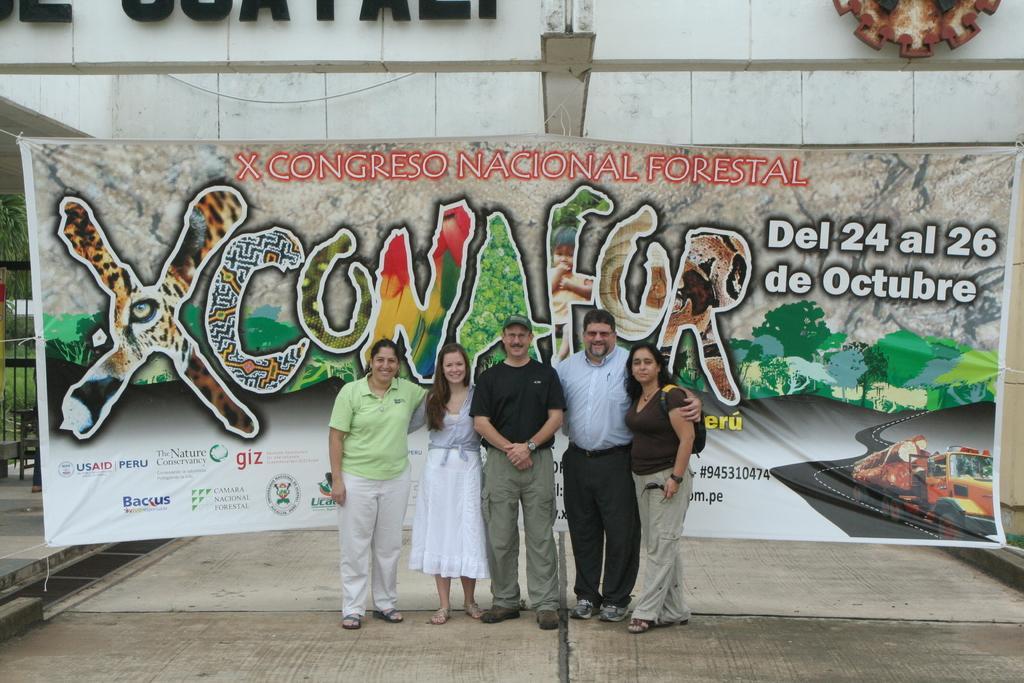Can you describe this image briefly? In this image there are five persons standing and smiling , and in the background there is a banner, building, gate, stool , plants, trees. 